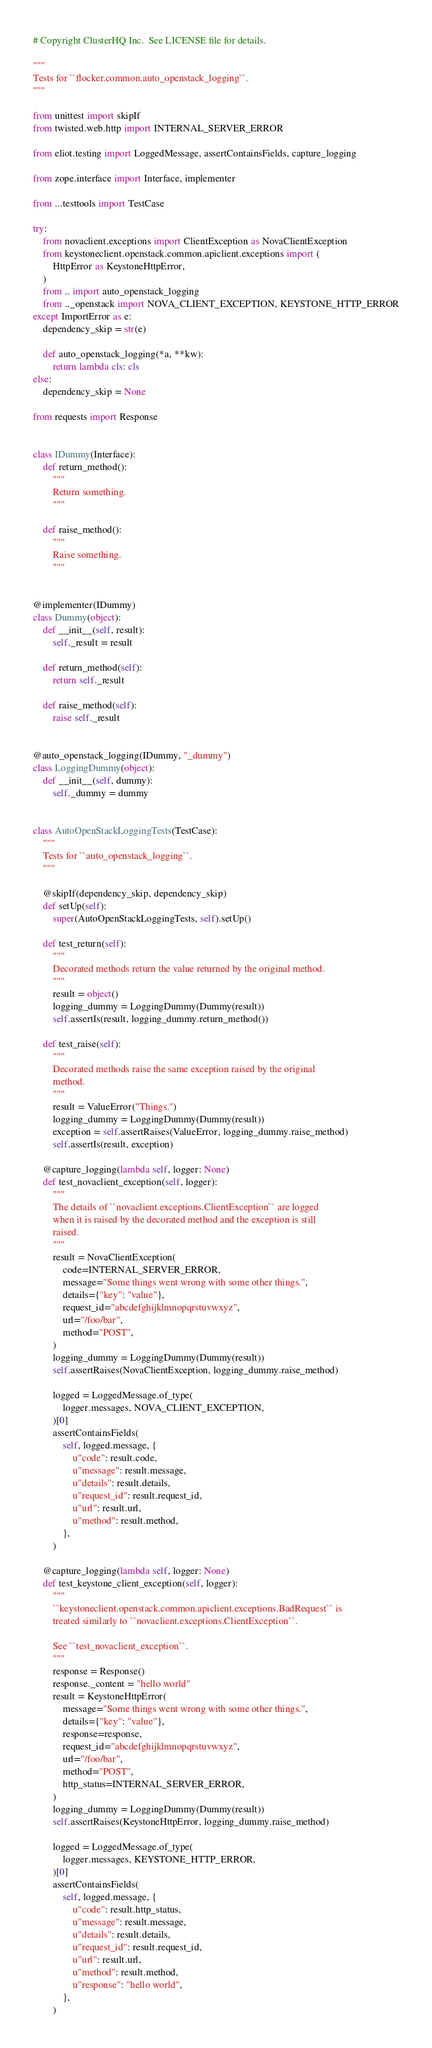Convert code to text. <code><loc_0><loc_0><loc_500><loc_500><_Python_># Copyright ClusterHQ Inc.  See LICENSE file for details.

"""
Tests for ``flocker.common.auto_openstack_logging``.
"""

from unittest import skipIf
from twisted.web.http import INTERNAL_SERVER_ERROR

from eliot.testing import LoggedMessage, assertContainsFields, capture_logging

from zope.interface import Interface, implementer

from ...testtools import TestCase

try:
    from novaclient.exceptions import ClientException as NovaClientException
    from keystoneclient.openstack.common.apiclient.exceptions import (
        HttpError as KeystoneHttpError,
    )
    from .. import auto_openstack_logging
    from .._openstack import NOVA_CLIENT_EXCEPTION, KEYSTONE_HTTP_ERROR
except ImportError as e:
    dependency_skip = str(e)

    def auto_openstack_logging(*a, **kw):
        return lambda cls: cls
else:
    dependency_skip = None

from requests import Response


class IDummy(Interface):
    def return_method():
        """
        Return something.
        """

    def raise_method():
        """
        Raise something.
        """


@implementer(IDummy)
class Dummy(object):
    def __init__(self, result):
        self._result = result

    def return_method(self):
        return self._result

    def raise_method(self):
        raise self._result


@auto_openstack_logging(IDummy, "_dummy")
class LoggingDummy(object):
    def __init__(self, dummy):
        self._dummy = dummy


class AutoOpenStackLoggingTests(TestCase):
    """
    Tests for ``auto_openstack_logging``.
    """

    @skipIf(dependency_skip, dependency_skip)
    def setUp(self):
        super(AutoOpenStackLoggingTests, self).setUp()

    def test_return(self):
        """
        Decorated methods return the value returned by the original method.
        """
        result = object()
        logging_dummy = LoggingDummy(Dummy(result))
        self.assertIs(result, logging_dummy.return_method())

    def test_raise(self):
        """
        Decorated methods raise the same exception raised by the original
        method.
        """
        result = ValueError("Things.")
        logging_dummy = LoggingDummy(Dummy(result))
        exception = self.assertRaises(ValueError, logging_dummy.raise_method)
        self.assertIs(result, exception)

    @capture_logging(lambda self, logger: None)
    def test_novaclient_exception(self, logger):
        """
        The details of ``novaclient.exceptions.ClientException`` are logged
        when it is raised by the decorated method and the exception is still
        raised.
        """
        result = NovaClientException(
            code=INTERNAL_SERVER_ERROR,
            message="Some things went wrong with some other things.",
            details={"key": "value"},
            request_id="abcdefghijklmnopqrstuvwxyz",
            url="/foo/bar",
            method="POST",
        )
        logging_dummy = LoggingDummy(Dummy(result))
        self.assertRaises(NovaClientException, logging_dummy.raise_method)

        logged = LoggedMessage.of_type(
            logger.messages, NOVA_CLIENT_EXCEPTION,
        )[0]
        assertContainsFields(
            self, logged.message, {
                u"code": result.code,
                u"message": result.message,
                u"details": result.details,
                u"request_id": result.request_id,
                u"url": result.url,
                u"method": result.method,
            },
        )

    @capture_logging(lambda self, logger: None)
    def test_keystone_client_exception(self, logger):
        """
        ``keystoneclient.openstack.common.apiclient.exceptions.BadRequest`` is
        treated similarly to ``novaclient.exceptions.ClientException``.

        See ``test_novaclient_exception``.
        """
        response = Response()
        response._content = "hello world"
        result = KeystoneHttpError(
            message="Some things went wrong with some other things.",
            details={"key": "value"},
            response=response,
            request_id="abcdefghijklmnopqrstuvwxyz",
            url="/foo/bar",
            method="POST",
            http_status=INTERNAL_SERVER_ERROR,
        )
        logging_dummy = LoggingDummy(Dummy(result))
        self.assertRaises(KeystoneHttpError, logging_dummy.raise_method)

        logged = LoggedMessage.of_type(
            logger.messages, KEYSTONE_HTTP_ERROR,
        )[0]
        assertContainsFields(
            self, logged.message, {
                u"code": result.http_status,
                u"message": result.message,
                u"details": result.details,
                u"request_id": result.request_id,
                u"url": result.url,
                u"method": result.method,
                u"response": "hello world",
            },
        )
</code> 